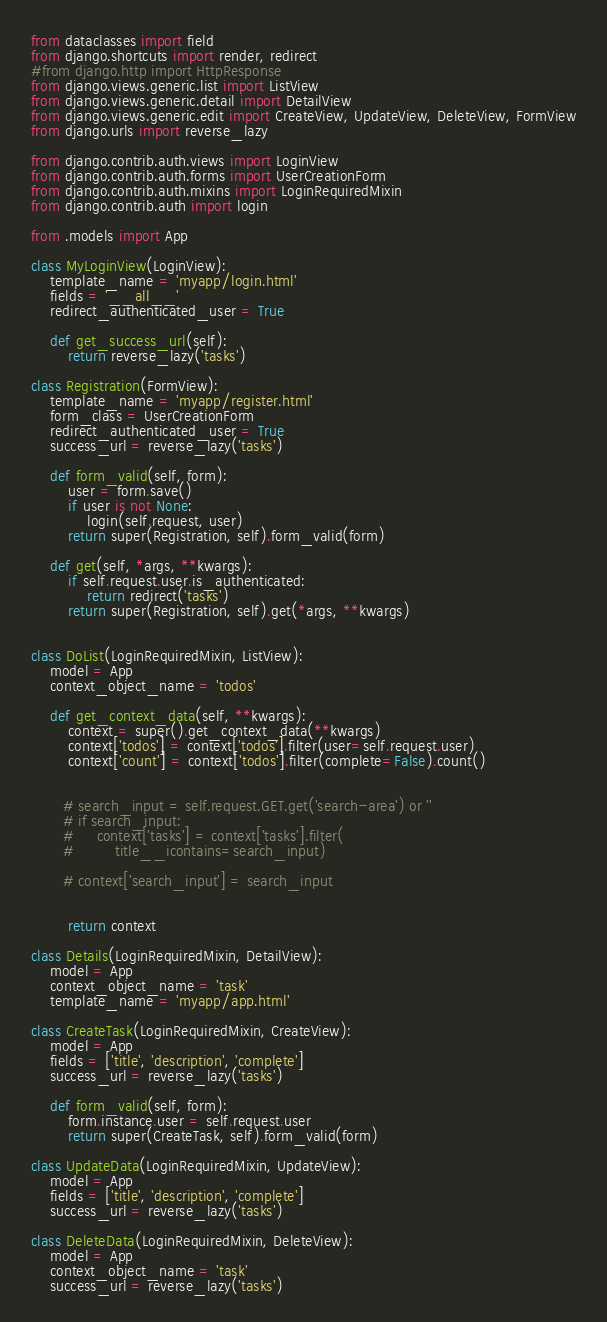Convert code to text. <code><loc_0><loc_0><loc_500><loc_500><_Python_>from dataclasses import field
from django.shortcuts import render, redirect
#from django.http import HttpResponse
from django.views.generic.list import ListView
from django.views.generic.detail import DetailView
from django.views.generic.edit import CreateView, UpdateView, DeleteView, FormView
from django.urls import reverse_lazy

from django.contrib.auth.views import LoginView
from django.contrib.auth.forms import UserCreationForm
from django.contrib.auth.mixins import LoginRequiredMixin
from django.contrib.auth import login

from .models import App

class MyLoginView(LoginView):
    template_name = 'myapp/login.html'
    fields = '__all__'
    redirect_authenticated_user = True

    def get_success_url(self):
        return reverse_lazy('tasks')

class Registration(FormView):
    template_name = 'myapp/register.html'
    form_class = UserCreationForm
    redirect_authenticated_user = True
    success_url = reverse_lazy('tasks')

    def form_valid(self, form):
        user = form.save()
        if user is not None:
            login(self.request, user)
        return super(Registration, self).form_valid(form)

    def get(self, *args, **kwargs):
        if self.request.user.is_authenticated:
            return redirect('tasks')
        return super(Registration, self).get(*args, **kwargs)


class DoList(LoginRequiredMixin, ListView):
    model = App 
    context_object_name = 'todos'

    def get_context_data(self, **kwargs):
        context = super().get_context_data(**kwargs)
        context['todos'] = context['todos'].filter(user=self.request.user)
        context['count'] = context['todos'].filter(complete=False).count()


       # search_input = self.request.GET.get('search-area') or ''
       # if search_input:
       #     context['tasks'] = context['tasks'].filter(
       #         title__icontains=search_input)

       # context['search_input'] = search_input


        return context

class Details(LoginRequiredMixin, DetailView):
    model = App
    context_object_name = 'task'
    template_name = 'myapp/app.html'

class CreateTask(LoginRequiredMixin, CreateView):
    model = App
    fields = ['title', 'description', 'complete']
    success_url = reverse_lazy('tasks')

    def form_valid(self, form):
        form.instance.user = self.request.user
        return super(CreateTask, self).form_valid(form)

class UpdateData(LoginRequiredMixin, UpdateView):
    model = App
    fields = ['title', 'description', 'complete']
    success_url = reverse_lazy('tasks')

class DeleteData(LoginRequiredMixin, DeleteView):
    model = App
    context_object_name = 'task'
    success_url = reverse_lazy('tasks')</code> 